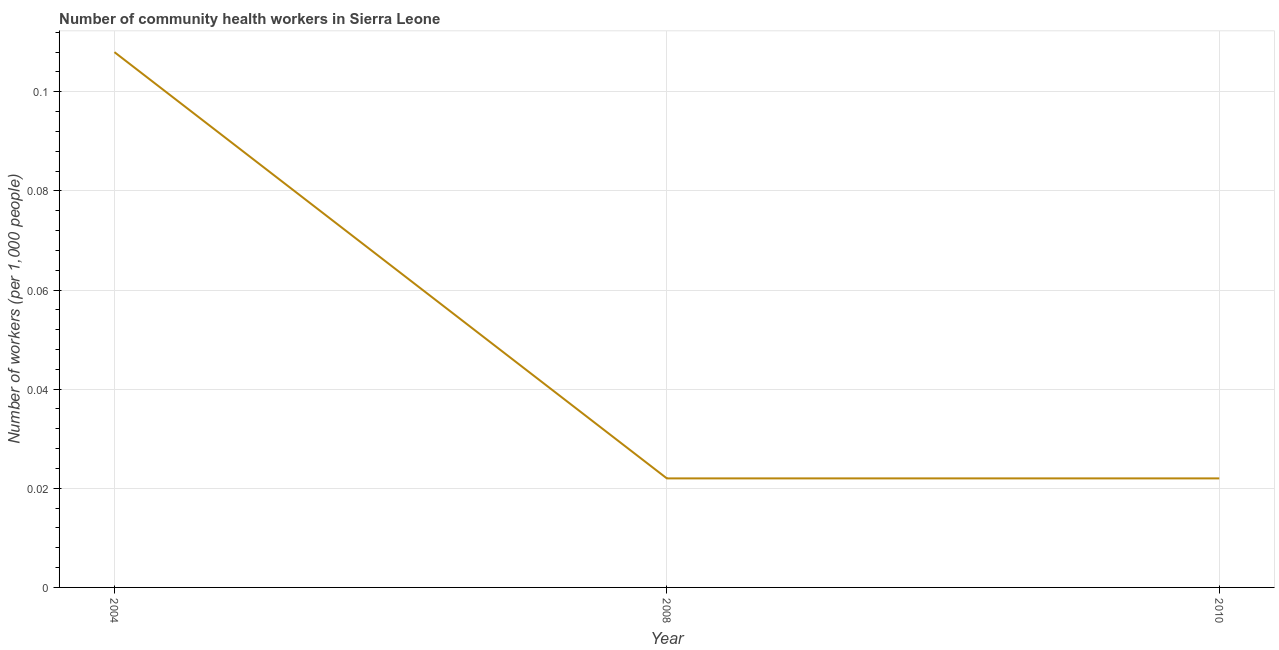What is the number of community health workers in 2008?
Your answer should be very brief. 0.02. Across all years, what is the maximum number of community health workers?
Offer a terse response. 0.11. Across all years, what is the minimum number of community health workers?
Give a very brief answer. 0.02. In which year was the number of community health workers maximum?
Provide a succinct answer. 2004. What is the sum of the number of community health workers?
Give a very brief answer. 0.15. What is the difference between the number of community health workers in 2004 and 2008?
Give a very brief answer. 0.09. What is the average number of community health workers per year?
Make the answer very short. 0.05. What is the median number of community health workers?
Make the answer very short. 0.02. Do a majority of the years between 2010 and 2004 (inclusive) have number of community health workers greater than 0.028 ?
Offer a very short reply. No. What is the ratio of the number of community health workers in 2004 to that in 2010?
Make the answer very short. 4.91. Is the number of community health workers in 2008 less than that in 2010?
Ensure brevity in your answer.  No. Is the difference between the number of community health workers in 2004 and 2008 greater than the difference between any two years?
Provide a succinct answer. Yes. What is the difference between the highest and the second highest number of community health workers?
Make the answer very short. 0.09. Is the sum of the number of community health workers in 2004 and 2010 greater than the maximum number of community health workers across all years?
Give a very brief answer. Yes. What is the difference between the highest and the lowest number of community health workers?
Provide a short and direct response. 0.09. Does the number of community health workers monotonically increase over the years?
Give a very brief answer. No. How many lines are there?
Offer a terse response. 1. Does the graph contain grids?
Make the answer very short. Yes. What is the title of the graph?
Keep it short and to the point. Number of community health workers in Sierra Leone. What is the label or title of the X-axis?
Provide a short and direct response. Year. What is the label or title of the Y-axis?
Provide a succinct answer. Number of workers (per 1,0 people). What is the Number of workers (per 1,000 people) of 2004?
Your answer should be compact. 0.11. What is the Number of workers (per 1,000 people) in 2008?
Ensure brevity in your answer.  0.02. What is the Number of workers (per 1,000 people) of 2010?
Make the answer very short. 0.02. What is the difference between the Number of workers (per 1,000 people) in 2004 and 2008?
Keep it short and to the point. 0.09. What is the difference between the Number of workers (per 1,000 people) in 2004 and 2010?
Your answer should be compact. 0.09. What is the ratio of the Number of workers (per 1,000 people) in 2004 to that in 2008?
Keep it short and to the point. 4.91. What is the ratio of the Number of workers (per 1,000 people) in 2004 to that in 2010?
Your answer should be compact. 4.91. 